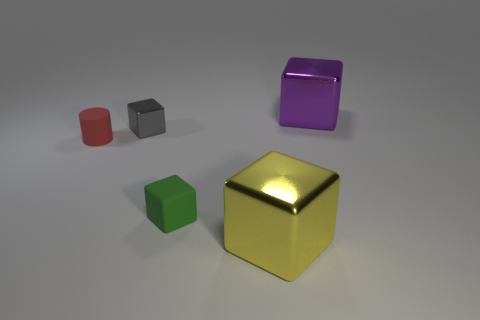There is a object that is the same size as the purple cube; what is its shape?
Provide a short and direct response. Cube. Is the number of large gray matte cylinders greater than the number of big purple objects?
Your answer should be very brief. No. The block that is both on the right side of the gray cube and behind the tiny matte cube is made of what material?
Give a very brief answer. Metal. What number of other things are there of the same material as the yellow object
Keep it short and to the point. 2. How many tiny objects are the same color as the tiny cylinder?
Offer a very short reply. 0. What size is the metal object in front of the small cube to the right of the metal block that is to the left of the green block?
Offer a terse response. Large. How many shiny objects are either tiny objects or tiny red blocks?
Give a very brief answer. 1. Do the big yellow thing and the metallic object that is on the left side of the big yellow shiny thing have the same shape?
Make the answer very short. Yes. Is the number of red cylinders in front of the yellow shiny block greater than the number of red matte cylinders that are behind the small gray shiny thing?
Ensure brevity in your answer.  No. Are there any other things that are the same color as the small matte block?
Your answer should be compact. No. 